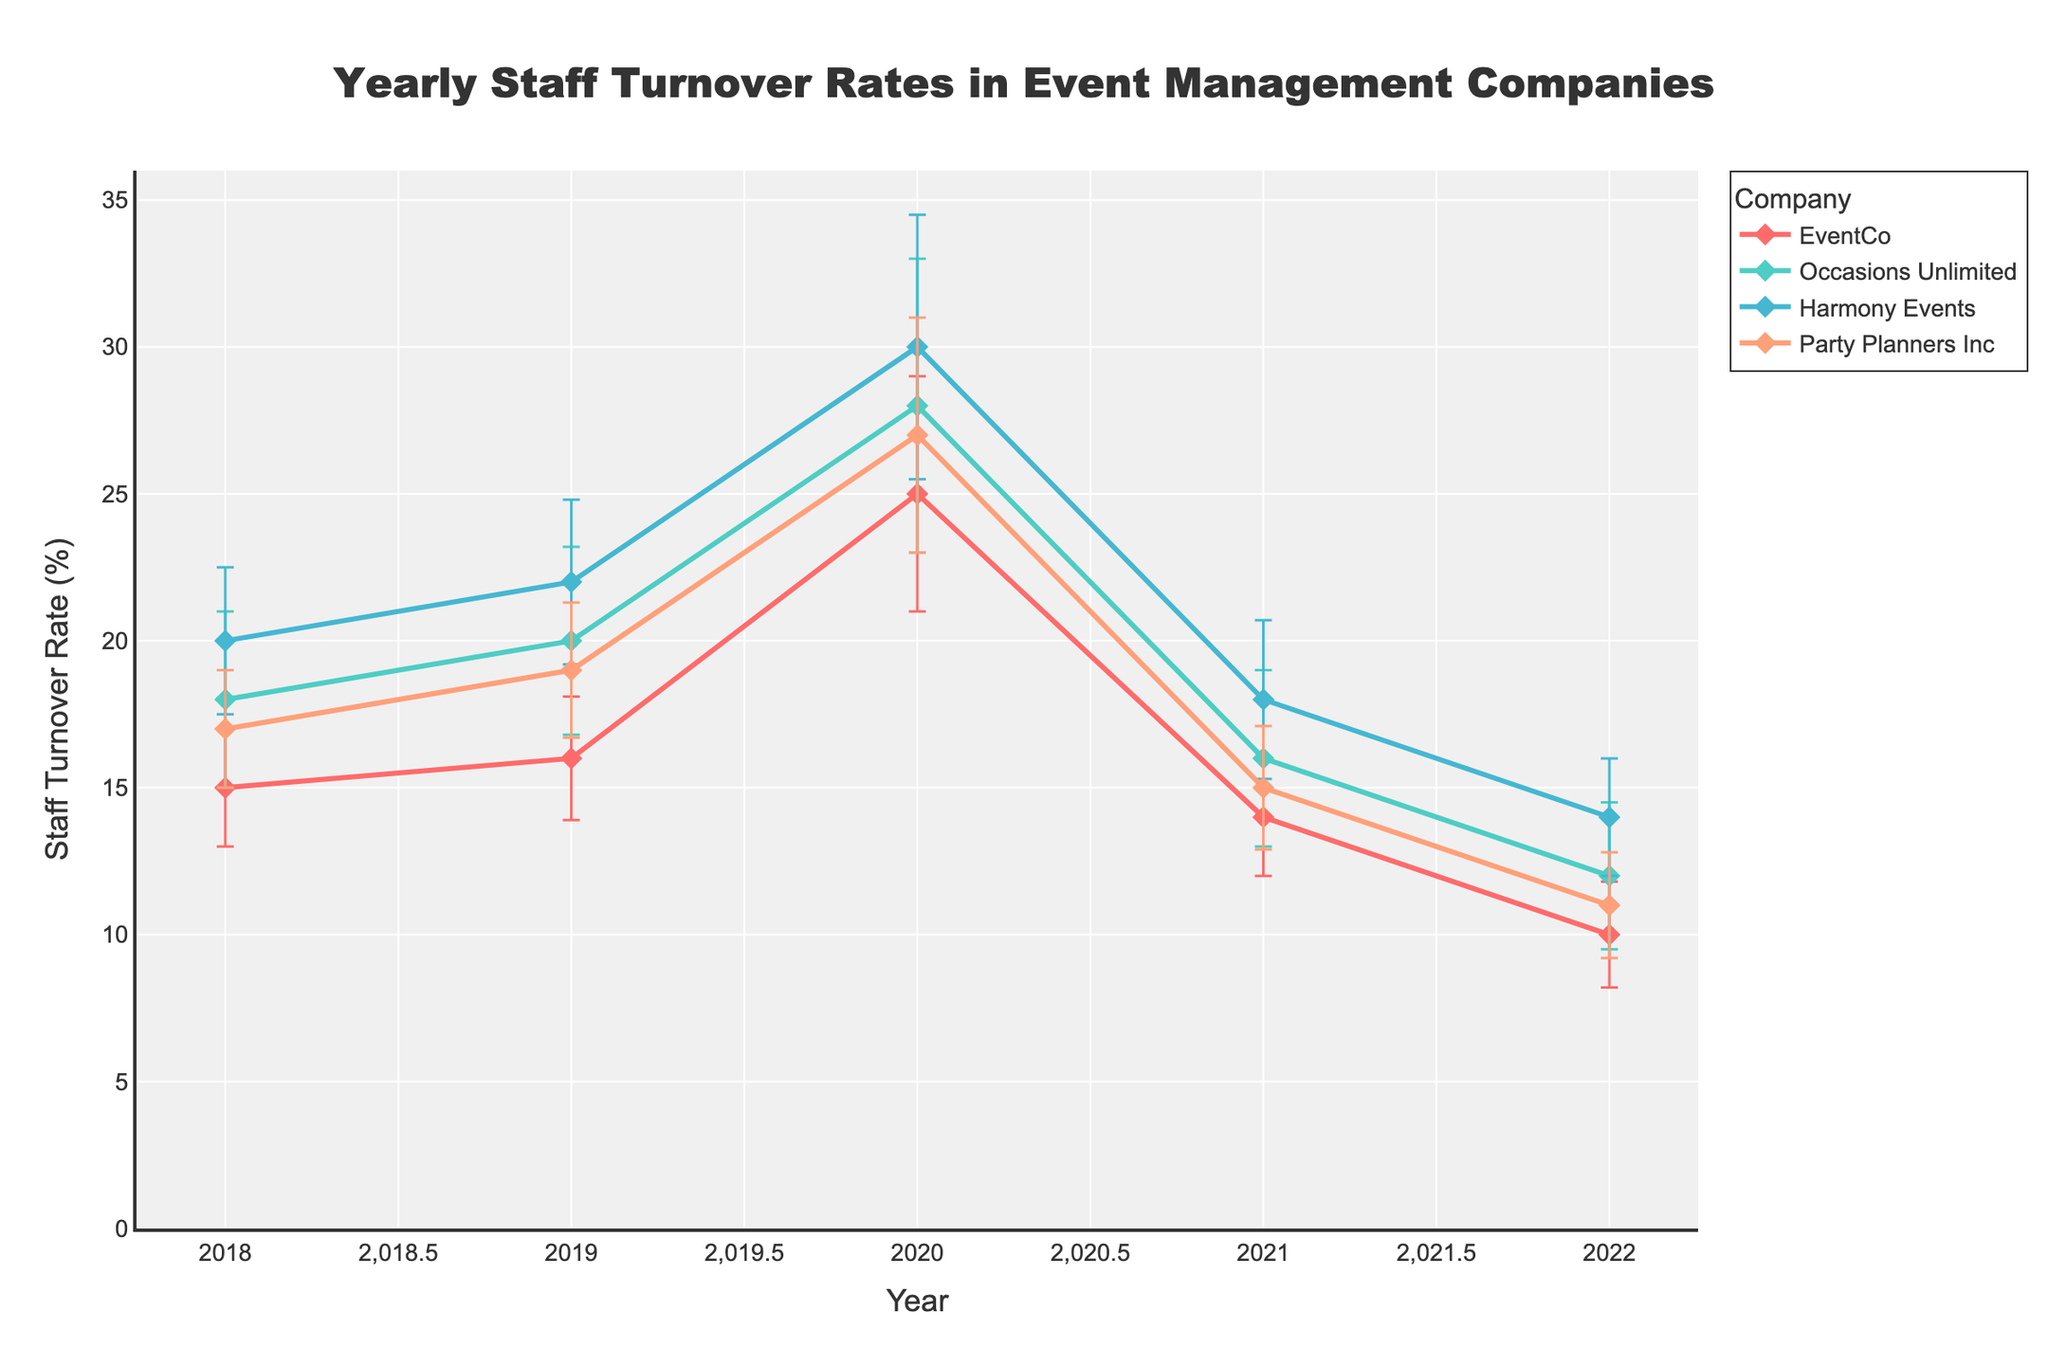Did the overall staff turnover rate for EventCo increase or decrease from 2018 to 2022? To determine this, we look at the staff turnover rates for EventCo for the years 2018 and 2022. In 2018, the turnover rate was 15%, and in 2022, it was 10%. Therefore, the staff turnover rate for EventCo decreased.
Answer: Decrease Which company had the highest staff turnover rate in 2020? To identify the company with the highest turnover rate for 2020, look at the data points for all companies in that year. The turnover rates were EventCo 25%, Occasions Unlimited 28%, Harmony Events 30%, Party Planners Inc 27%. Harmony Events had the highest rate.
Answer: Harmony Events For which years did Party Planners Inc experience a decrease in staff turnover rate compared to the previous year? To determine the years of decrease, compare the staff turnover rates year by year for Party Planners Inc: 2018 (17%) to 2019 (19%) is an increase, 2019 to 2020 (27%) is an increase, 2020 to 2021 (15%) is a decrease, and 2021 to 2022 (11%) is a decrease. So, the years are 2021 and 2022.
Answer: 2021, 2022 What was the average staff turnover rate for Harmony Events during the years 2020 to 2022? To find the average turnover rate, sum the rates for those years and divide by the number of years. For Harmony Events: (30% in 2020 + 18% in 2021 + 14% in 2022) / 3 = 62% / 3 = 20.67%.
Answer: 20.67% How did the economic impact error compare between EventCo and Occasions Unlimited in 2020? The economic impact error for EventCo in 2020 was ±4%, and for Occasions Unlimited, it was ±5%. Occasions Unlimited had a higher economic impact error.
Answer: Occasions Unlimited had a higher error What trend did Occasions Unlimited's staff turnover rate follow from 2018 to 2022? To identify the trend, observe the staff turnover rate for Occasions Unlimited for each year: 18% in 2018, 20% in 2019, 28% in 2020, 16% in 2021, and 12% in 2022. The trend is an initial increase until 2020 followed by a decrease in 2021 and 2022.
Answer: Increase until 2020, then decrease Which company had the most stable staff turnover rate from 2018 to 2022 if we only consider the rates and not the error bars? Stability can be judged based on the smallest differences in rates over the years. Reviewing each company, EventCo's rates were 15%, 16%, 25%, 14%, 10%. Occasions Unlimited's were 18%, 20%, 28%, 16%, 12%. Harmony Events' were 20%, 22%, 30%, 18%, 14%. Party Planners Inc's were 17%, 19%, 27%, 15%, 11%. EventCo shows less variability as compared to others.
Answer: EventCo 